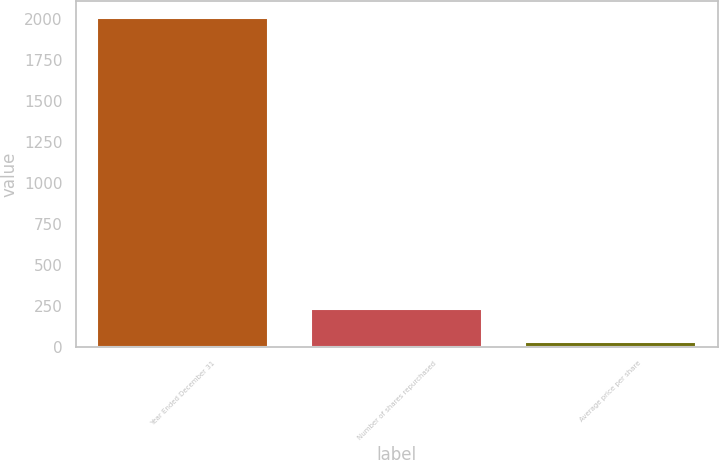Convert chart to OTSL. <chart><loc_0><loc_0><loc_500><loc_500><bar_chart><fcel>Year Ended December 31<fcel>Number of shares repurchased<fcel>Average price per share<nl><fcel>2010<fcel>229.73<fcel>31.92<nl></chart> 